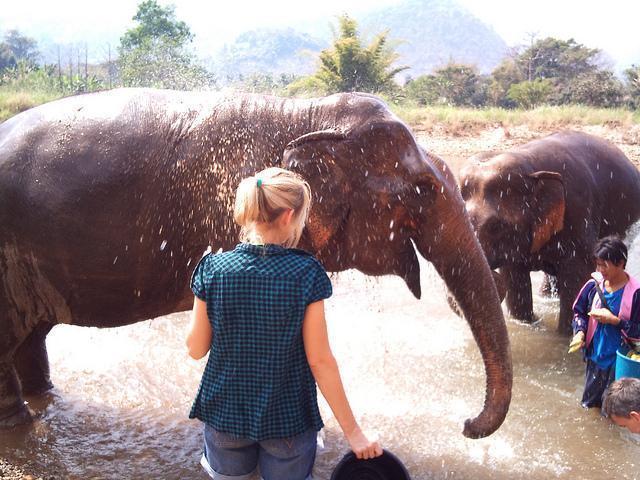Which part of the Elephant's body work to cool their body?
Make your selection from the four choices given to correctly answer the question.
Options: Leg, trunk, ear, skin. Trunk. 